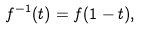<formula> <loc_0><loc_0><loc_500><loc_500>f ^ { - 1 } ( t ) = f ( 1 - t ) ,</formula> 